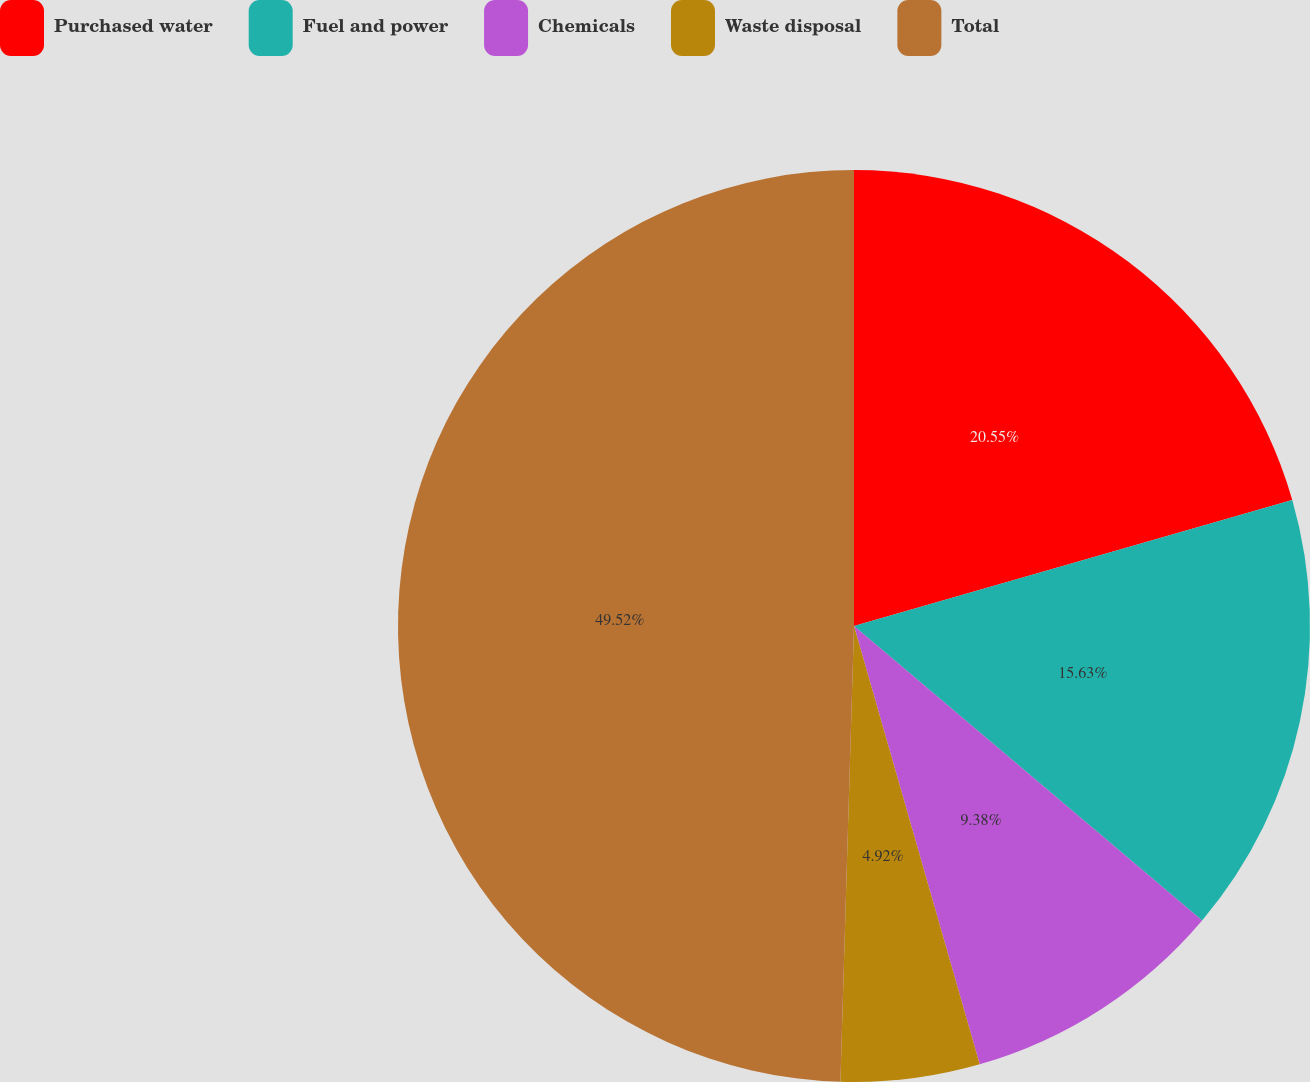<chart> <loc_0><loc_0><loc_500><loc_500><pie_chart><fcel>Purchased water<fcel>Fuel and power<fcel>Chemicals<fcel>Waste disposal<fcel>Total<nl><fcel>20.55%<fcel>15.63%<fcel>9.38%<fcel>4.92%<fcel>49.53%<nl></chart> 